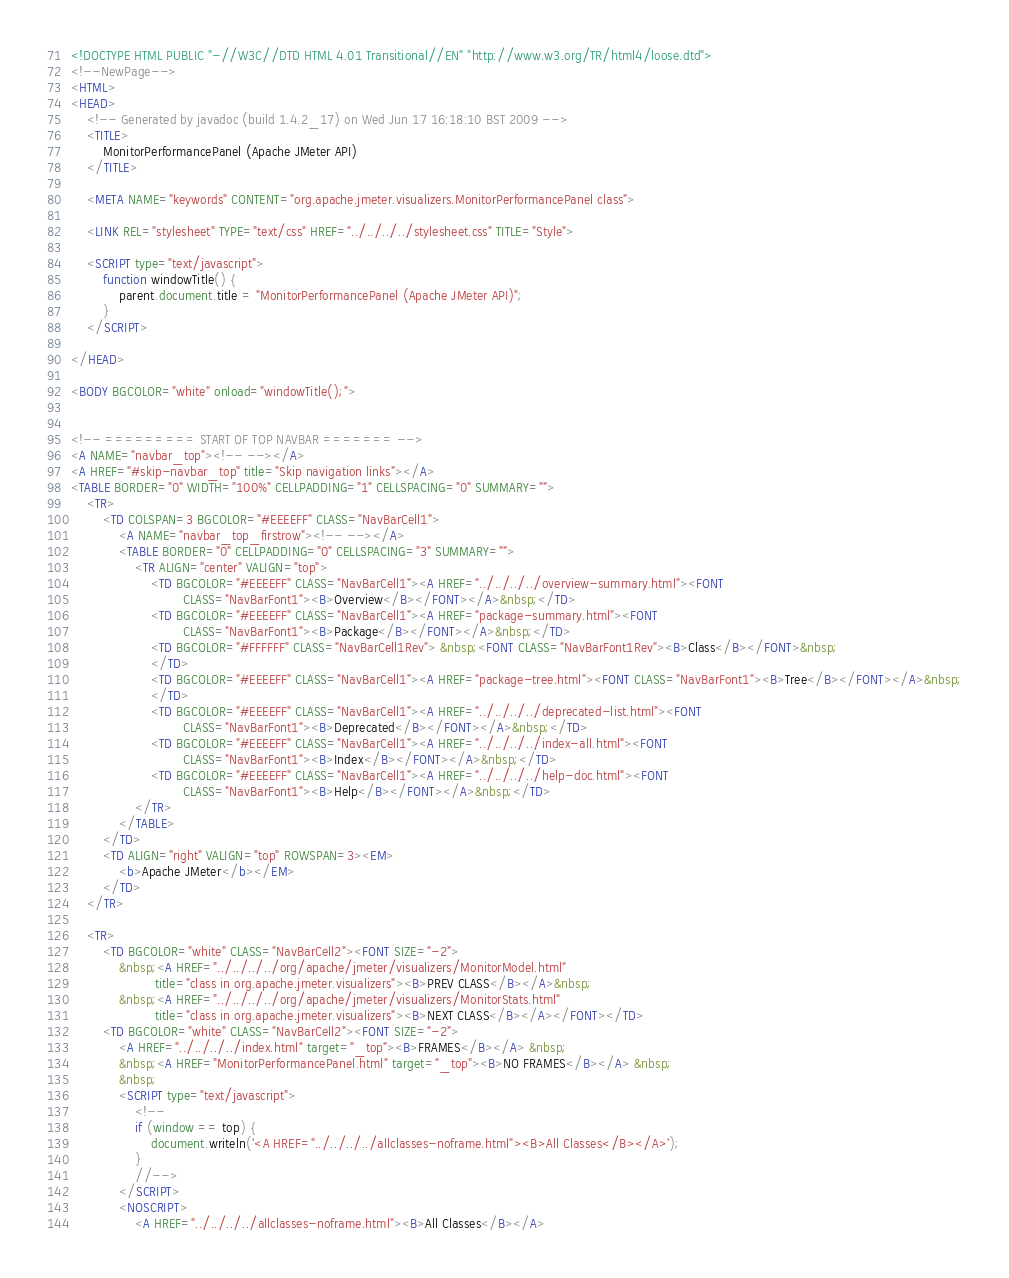<code> <loc_0><loc_0><loc_500><loc_500><_HTML_><!DOCTYPE HTML PUBLIC "-//W3C//DTD HTML 4.01 Transitional//EN" "http://www.w3.org/TR/html4/loose.dtd">
<!--NewPage-->
<HTML>
<HEAD>
    <!-- Generated by javadoc (build 1.4.2_17) on Wed Jun 17 16:18:10 BST 2009 -->
    <TITLE>
        MonitorPerformancePanel (Apache JMeter API)
    </TITLE>

    <META NAME="keywords" CONTENT="org.apache.jmeter.visualizers.MonitorPerformancePanel class">

    <LINK REL="stylesheet" TYPE="text/css" HREF="../../../../stylesheet.css" TITLE="Style">

    <SCRIPT type="text/javascript">
        function windowTitle() {
            parent.document.title = "MonitorPerformancePanel (Apache JMeter API)";
        }
    </SCRIPT>

</HEAD>

<BODY BGCOLOR="white" onload="windowTitle();">


<!-- ========= START OF TOP NAVBAR ======= -->
<A NAME="navbar_top"><!-- --></A>
<A HREF="#skip-navbar_top" title="Skip navigation links"></A>
<TABLE BORDER="0" WIDTH="100%" CELLPADDING="1" CELLSPACING="0" SUMMARY="">
    <TR>
        <TD COLSPAN=3 BGCOLOR="#EEEEFF" CLASS="NavBarCell1">
            <A NAME="navbar_top_firstrow"><!-- --></A>
            <TABLE BORDER="0" CELLPADDING="0" CELLSPACING="3" SUMMARY="">
                <TR ALIGN="center" VALIGN="top">
                    <TD BGCOLOR="#EEEEFF" CLASS="NavBarCell1"><A HREF="../../../../overview-summary.html"><FONT
                            CLASS="NavBarFont1"><B>Overview</B></FONT></A>&nbsp;</TD>
                    <TD BGCOLOR="#EEEEFF" CLASS="NavBarCell1"><A HREF="package-summary.html"><FONT
                            CLASS="NavBarFont1"><B>Package</B></FONT></A>&nbsp;</TD>
                    <TD BGCOLOR="#FFFFFF" CLASS="NavBarCell1Rev"> &nbsp;<FONT CLASS="NavBarFont1Rev"><B>Class</B></FONT>&nbsp;
                    </TD>
                    <TD BGCOLOR="#EEEEFF" CLASS="NavBarCell1"><A HREF="package-tree.html"><FONT CLASS="NavBarFont1"><B>Tree</B></FONT></A>&nbsp;
                    </TD>
                    <TD BGCOLOR="#EEEEFF" CLASS="NavBarCell1"><A HREF="../../../../deprecated-list.html"><FONT
                            CLASS="NavBarFont1"><B>Deprecated</B></FONT></A>&nbsp;</TD>
                    <TD BGCOLOR="#EEEEFF" CLASS="NavBarCell1"><A HREF="../../../../index-all.html"><FONT
                            CLASS="NavBarFont1"><B>Index</B></FONT></A>&nbsp;</TD>
                    <TD BGCOLOR="#EEEEFF" CLASS="NavBarCell1"><A HREF="../../../../help-doc.html"><FONT
                            CLASS="NavBarFont1"><B>Help</B></FONT></A>&nbsp;</TD>
                </TR>
            </TABLE>
        </TD>
        <TD ALIGN="right" VALIGN="top" ROWSPAN=3><EM>
            <b>Apache JMeter</b></EM>
        </TD>
    </TR>

    <TR>
        <TD BGCOLOR="white" CLASS="NavBarCell2"><FONT SIZE="-2">
            &nbsp;<A HREF="../../../../org/apache/jmeter/visualizers/MonitorModel.html"
                     title="class in org.apache.jmeter.visualizers"><B>PREV CLASS</B></A>&nbsp;
            &nbsp;<A HREF="../../../../org/apache/jmeter/visualizers/MonitorStats.html"
                     title="class in org.apache.jmeter.visualizers"><B>NEXT CLASS</B></A></FONT></TD>
        <TD BGCOLOR="white" CLASS="NavBarCell2"><FONT SIZE="-2">
            <A HREF="../../../../index.html" target="_top"><B>FRAMES</B></A> &nbsp;
            &nbsp;<A HREF="MonitorPerformancePanel.html" target="_top"><B>NO FRAMES</B></A> &nbsp;
            &nbsp;
            <SCRIPT type="text/javascript">
                <!--
                if (window == top) {
                    document.writeln('<A HREF="../../../../allclasses-noframe.html"><B>All Classes</B></A>');
                }
                //-->
            </SCRIPT>
            <NOSCRIPT>
                <A HREF="../../../../allclasses-noframe.html"><B>All Classes</B></A></code> 